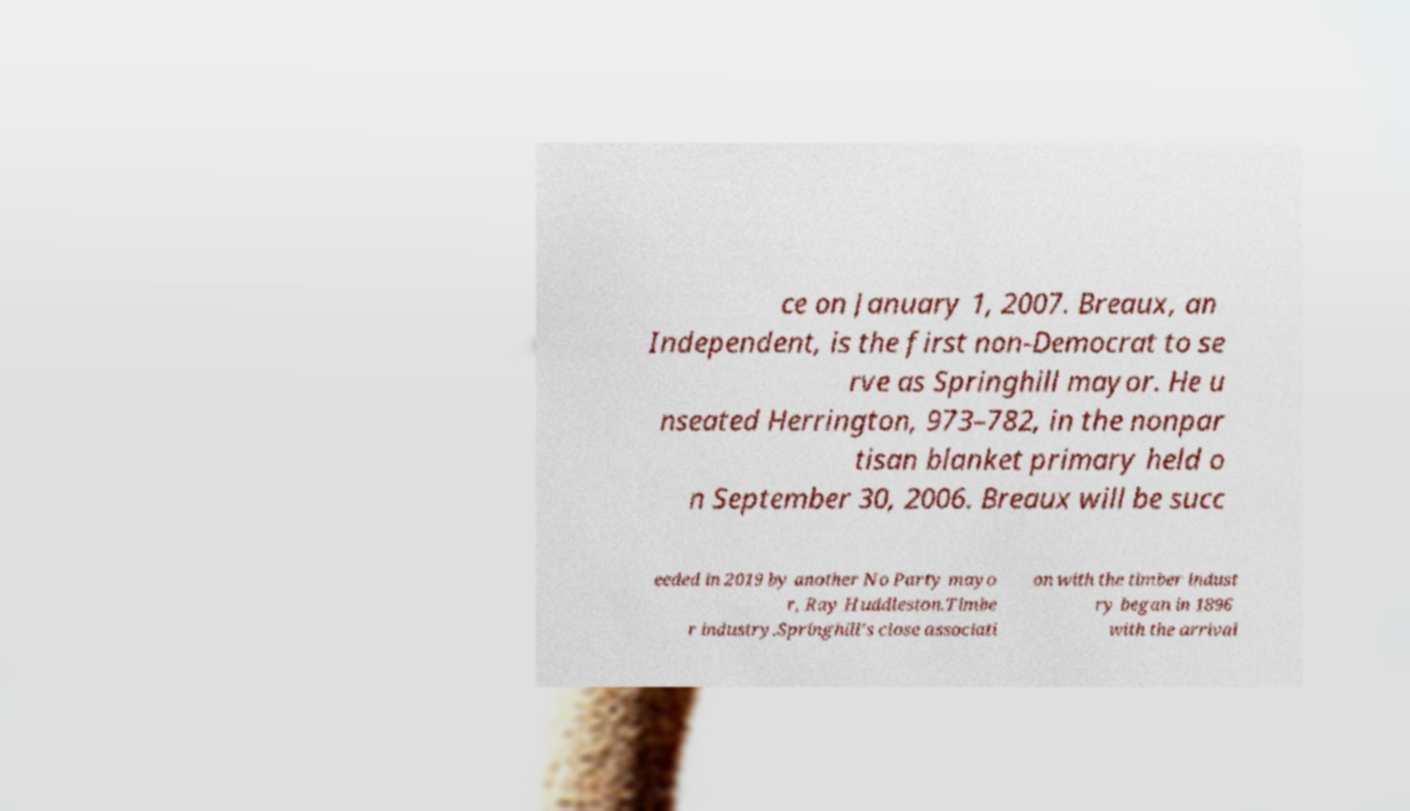Can you accurately transcribe the text from the provided image for me? ce on January 1, 2007. Breaux, an Independent, is the first non-Democrat to se rve as Springhill mayor. He u nseated Herrington, 973–782, in the nonpar tisan blanket primary held o n September 30, 2006. Breaux will be succ eeded in 2019 by another No Party mayo r, Ray Huddleston.Timbe r industry.Springhill's close associati on with the timber indust ry began in 1896 with the arrival 